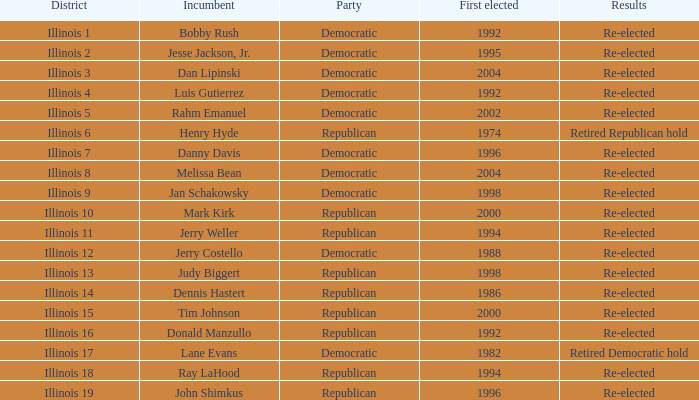When was the first elected date of the republican who achieved retired republican hold results? 1974.0. 